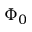Convert formula to latex. <formula><loc_0><loc_0><loc_500><loc_500>\Phi _ { 0 }</formula> 